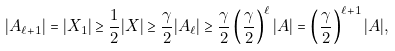Convert formula to latex. <formula><loc_0><loc_0><loc_500><loc_500>| A _ { \ell + 1 } | = | X _ { 1 } | \geq \frac { 1 } { 2 } | X | \geq \frac { \gamma } { 2 } | A _ { \ell } | \geq \frac { \gamma } { 2 } \left ( \frac { \gamma } { 2 } \right ) ^ { \ell } | A | = \left ( \frac { \gamma } { 2 } \right ) ^ { \ell + 1 } | A | ,</formula> 